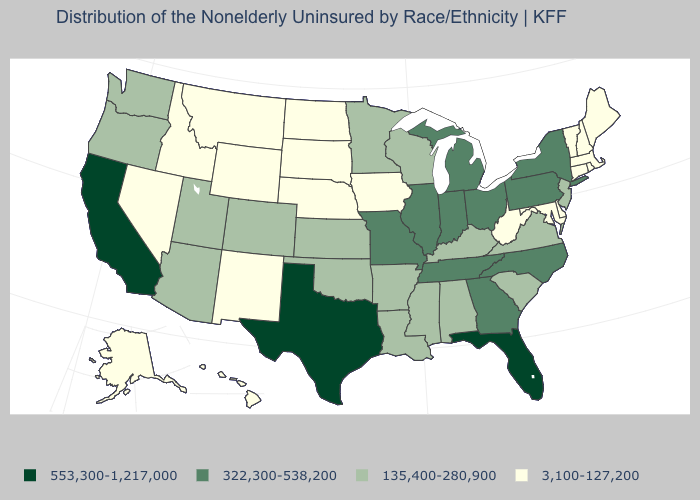Name the states that have a value in the range 3,100-127,200?
Quick response, please. Alaska, Connecticut, Delaware, Hawaii, Idaho, Iowa, Maine, Maryland, Massachusetts, Montana, Nebraska, Nevada, New Hampshire, New Mexico, North Dakota, Rhode Island, South Dakota, Vermont, West Virginia, Wyoming. Which states have the lowest value in the USA?
Concise answer only. Alaska, Connecticut, Delaware, Hawaii, Idaho, Iowa, Maine, Maryland, Massachusetts, Montana, Nebraska, Nevada, New Hampshire, New Mexico, North Dakota, Rhode Island, South Dakota, Vermont, West Virginia, Wyoming. What is the value of Alaska?
Be succinct. 3,100-127,200. What is the value of Tennessee?
Short answer required. 322,300-538,200. What is the value of New Mexico?
Keep it brief. 3,100-127,200. Which states have the highest value in the USA?
Answer briefly. California, Florida, Texas. What is the highest value in the USA?
Be succinct. 553,300-1,217,000. Which states have the highest value in the USA?
Short answer required. California, Florida, Texas. Does North Carolina have the same value as North Dakota?
Write a very short answer. No. Among the states that border Nebraska , does Iowa have the highest value?
Concise answer only. No. Name the states that have a value in the range 553,300-1,217,000?
Answer briefly. California, Florida, Texas. Among the states that border South Carolina , which have the highest value?
Concise answer only. Georgia, North Carolina. What is the value of Ohio?
Write a very short answer. 322,300-538,200. Does Oregon have the lowest value in the West?
Write a very short answer. No. What is the value of Wyoming?
Be succinct. 3,100-127,200. 